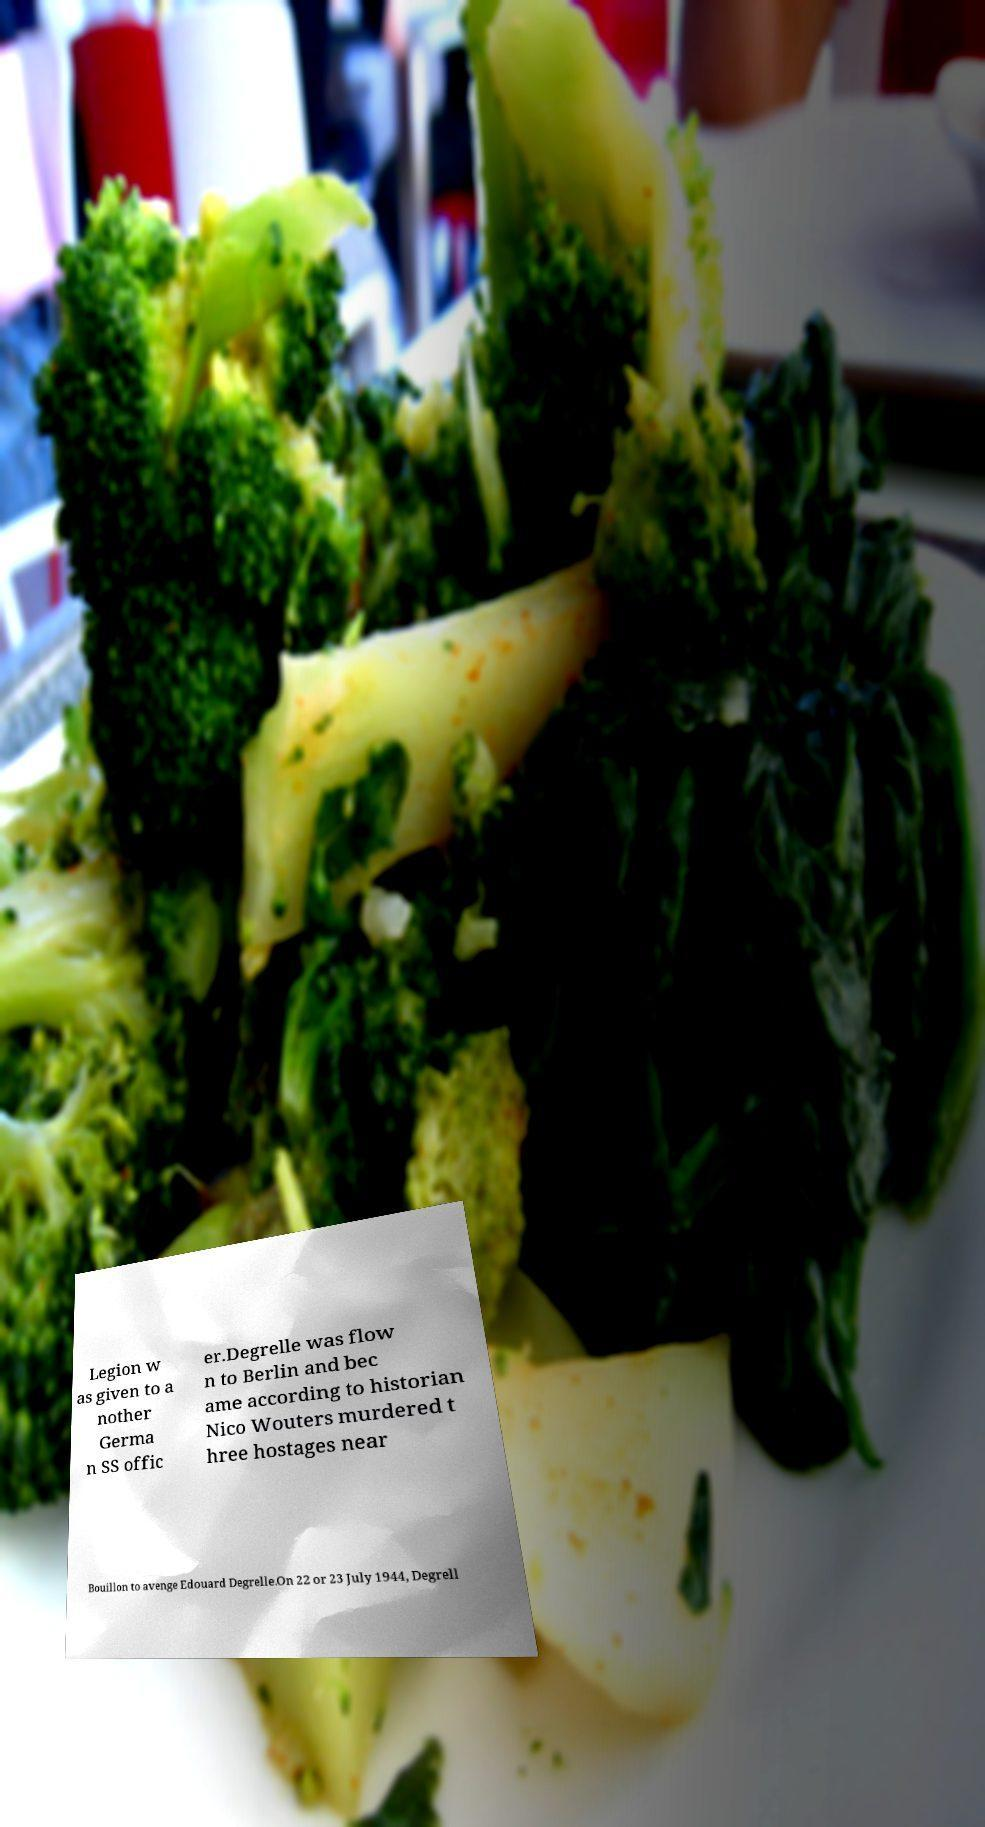Can you read and provide the text displayed in the image?This photo seems to have some interesting text. Can you extract and type it out for me? Legion w as given to a nother Germa n SS offic er.Degrelle was flow n to Berlin and bec ame according to historian Nico Wouters murdered t hree hostages near Bouillon to avenge Edouard Degrelle.On 22 or 23 July 1944, Degrell 